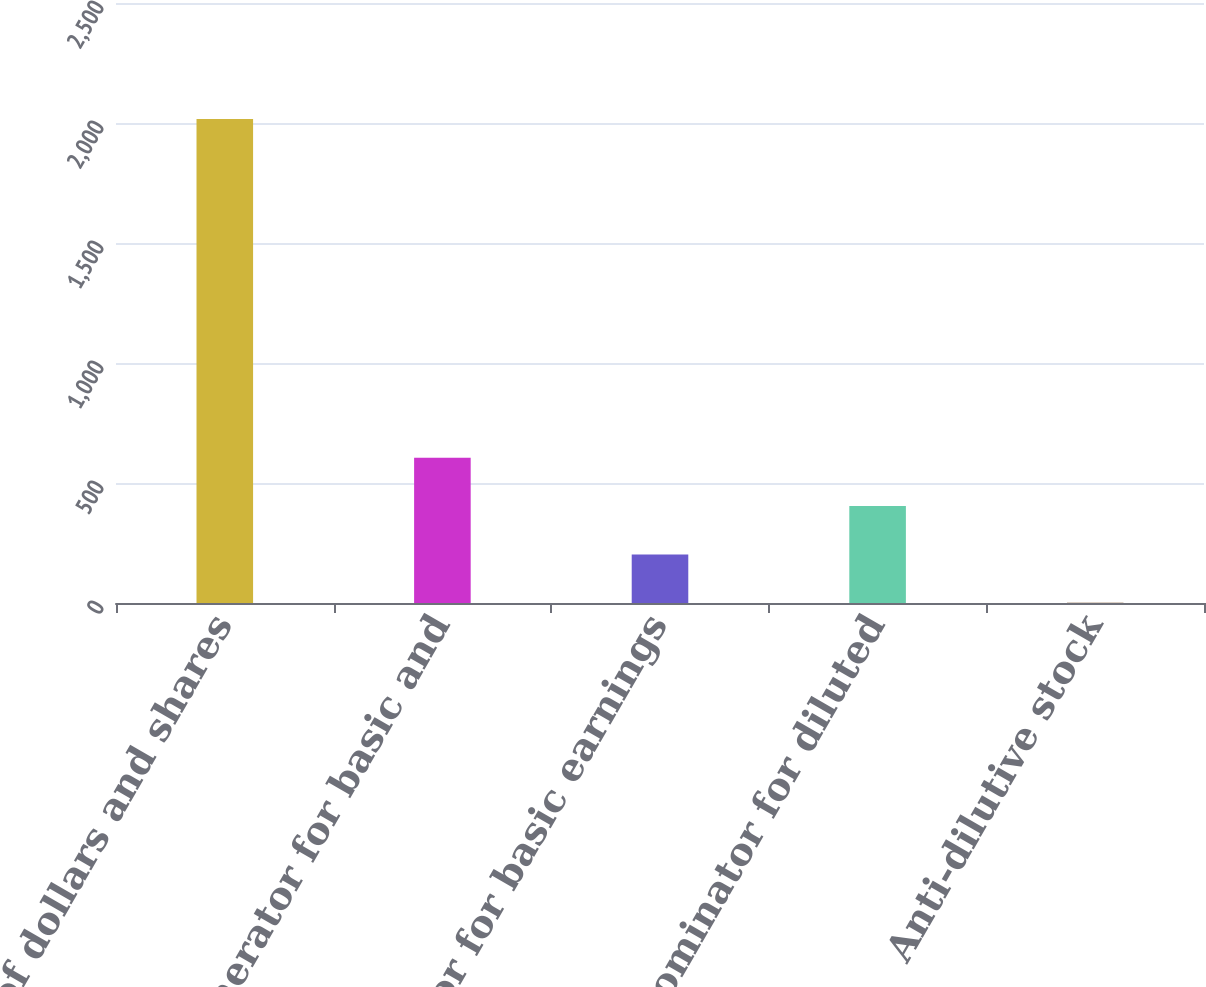Convert chart to OTSL. <chart><loc_0><loc_0><loc_500><loc_500><bar_chart><fcel>Millions of dollars and shares<fcel>Numerator for basic and<fcel>Denominator for basic earnings<fcel>Denominator for diluted<fcel>Anti-dilutive stock<nl><fcel>2017<fcel>605.52<fcel>202.24<fcel>403.88<fcel>0.6<nl></chart> 